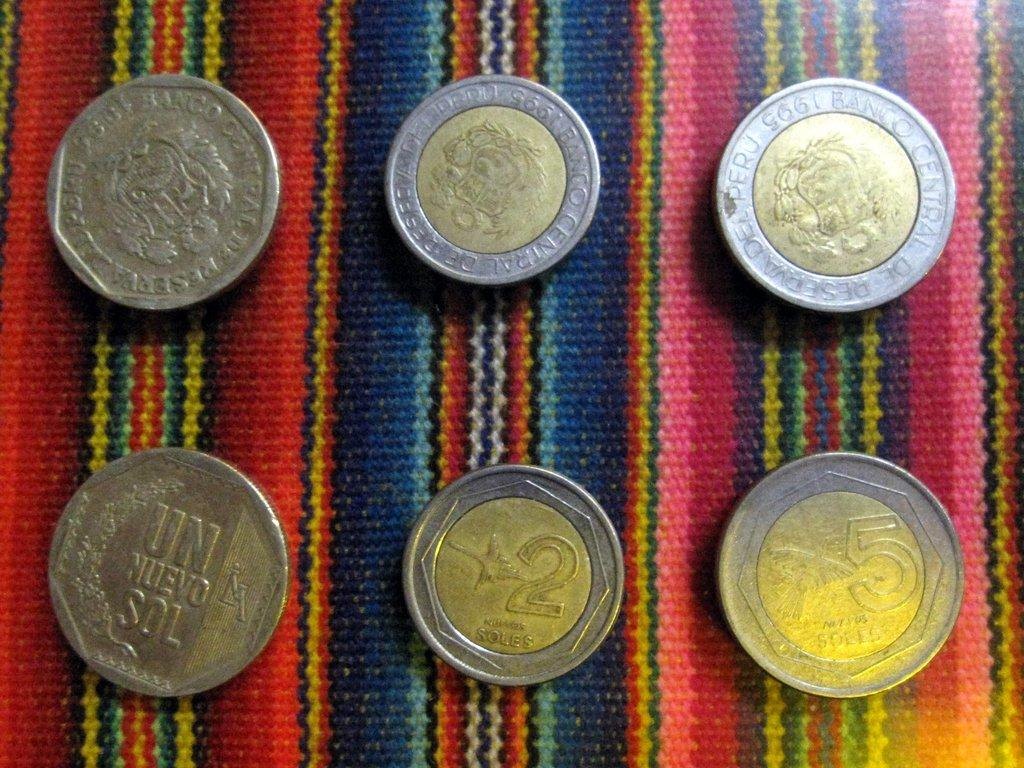<image>
Present a compact description of the photo's key features. several coins of silver and bronze on a table including a 2 Soles 